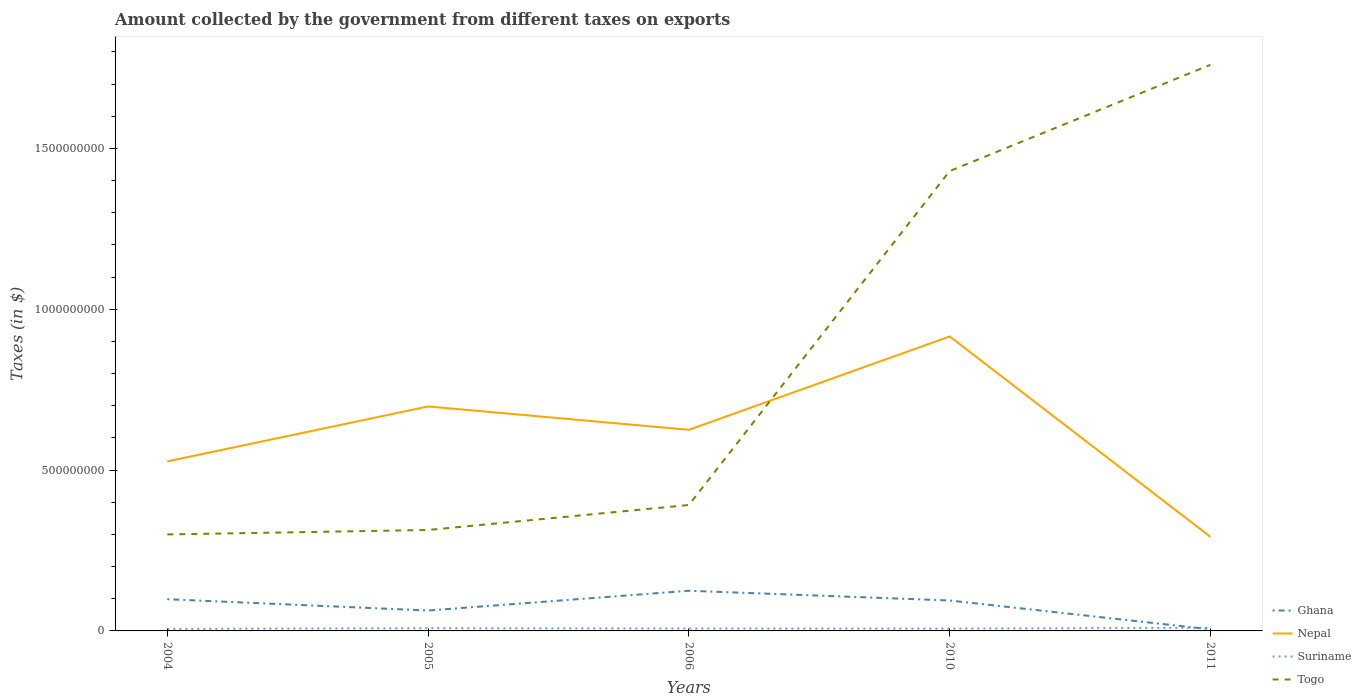Does the line corresponding to Togo intersect with the line corresponding to Ghana?
Keep it short and to the point. No. Across all years, what is the maximum amount collected by the government from taxes on exports in Togo?
Make the answer very short. 3.00e+08. What is the total amount collected by the government from taxes on exports in Suriname in the graph?
Provide a succinct answer. -3.63e+06. What is the difference between the highest and the second highest amount collected by the government from taxes on exports in Suriname?
Your answer should be compact. 3.63e+06. What is the difference between the highest and the lowest amount collected by the government from taxes on exports in Nepal?
Offer a very short reply. 3. Is the amount collected by the government from taxes on exports in Togo strictly greater than the amount collected by the government from taxes on exports in Ghana over the years?
Your response must be concise. No. How many lines are there?
Give a very brief answer. 4. What is the difference between two consecutive major ticks on the Y-axis?
Give a very brief answer. 5.00e+08. Are the values on the major ticks of Y-axis written in scientific E-notation?
Provide a succinct answer. No. Does the graph contain any zero values?
Make the answer very short. No. Where does the legend appear in the graph?
Give a very brief answer. Bottom right. How many legend labels are there?
Your response must be concise. 4. How are the legend labels stacked?
Provide a succinct answer. Vertical. What is the title of the graph?
Keep it short and to the point. Amount collected by the government from different taxes on exports. Does "Timor-Leste" appear as one of the legend labels in the graph?
Your answer should be very brief. No. What is the label or title of the Y-axis?
Offer a terse response. Taxes (in $). What is the Taxes (in $) in Ghana in 2004?
Provide a short and direct response. 9.86e+07. What is the Taxes (in $) of Nepal in 2004?
Give a very brief answer. 5.27e+08. What is the Taxes (in $) of Suriname in 2004?
Offer a very short reply. 6.30e+06. What is the Taxes (in $) in Togo in 2004?
Keep it short and to the point. 3.00e+08. What is the Taxes (in $) of Ghana in 2005?
Provide a succinct answer. 6.34e+07. What is the Taxes (in $) in Nepal in 2005?
Offer a terse response. 6.98e+08. What is the Taxes (in $) of Suriname in 2005?
Offer a very short reply. 8.52e+06. What is the Taxes (in $) of Togo in 2005?
Your answer should be very brief. 3.14e+08. What is the Taxes (in $) in Ghana in 2006?
Your answer should be very brief. 1.25e+08. What is the Taxes (in $) in Nepal in 2006?
Give a very brief answer. 6.25e+08. What is the Taxes (in $) in Suriname in 2006?
Give a very brief answer. 7.49e+06. What is the Taxes (in $) of Togo in 2006?
Offer a terse response. 3.91e+08. What is the Taxes (in $) of Ghana in 2010?
Your response must be concise. 9.47e+07. What is the Taxes (in $) in Nepal in 2010?
Offer a very short reply. 9.15e+08. What is the Taxes (in $) of Suriname in 2010?
Your answer should be very brief. 7.16e+06. What is the Taxes (in $) of Togo in 2010?
Provide a short and direct response. 1.43e+09. What is the Taxes (in $) of Ghana in 2011?
Offer a very short reply. 5.00e+06. What is the Taxes (in $) in Nepal in 2011?
Provide a succinct answer. 2.92e+08. What is the Taxes (in $) of Suriname in 2011?
Offer a very short reply. 9.93e+06. What is the Taxes (in $) in Togo in 2011?
Your answer should be compact. 1.76e+09. Across all years, what is the maximum Taxes (in $) in Ghana?
Keep it short and to the point. 1.25e+08. Across all years, what is the maximum Taxes (in $) in Nepal?
Ensure brevity in your answer.  9.15e+08. Across all years, what is the maximum Taxes (in $) in Suriname?
Your answer should be compact. 9.93e+06. Across all years, what is the maximum Taxes (in $) of Togo?
Provide a short and direct response. 1.76e+09. Across all years, what is the minimum Taxes (in $) of Nepal?
Offer a very short reply. 2.92e+08. Across all years, what is the minimum Taxes (in $) of Suriname?
Ensure brevity in your answer.  6.30e+06. Across all years, what is the minimum Taxes (in $) of Togo?
Give a very brief answer. 3.00e+08. What is the total Taxes (in $) of Ghana in the graph?
Give a very brief answer. 3.87e+08. What is the total Taxes (in $) of Nepal in the graph?
Offer a very short reply. 3.06e+09. What is the total Taxes (in $) in Suriname in the graph?
Offer a very short reply. 3.94e+07. What is the total Taxes (in $) in Togo in the graph?
Your response must be concise. 4.19e+09. What is the difference between the Taxes (in $) of Ghana in 2004 and that in 2005?
Offer a very short reply. 3.51e+07. What is the difference between the Taxes (in $) of Nepal in 2004 and that in 2005?
Give a very brief answer. -1.71e+08. What is the difference between the Taxes (in $) of Suriname in 2004 and that in 2005?
Give a very brief answer. -2.22e+06. What is the difference between the Taxes (in $) in Togo in 2004 and that in 2005?
Your answer should be very brief. -1.38e+07. What is the difference between the Taxes (in $) of Ghana in 2004 and that in 2006?
Provide a succinct answer. -2.63e+07. What is the difference between the Taxes (in $) in Nepal in 2004 and that in 2006?
Provide a succinct answer. -9.82e+07. What is the difference between the Taxes (in $) in Suriname in 2004 and that in 2006?
Keep it short and to the point. -1.19e+06. What is the difference between the Taxes (in $) of Togo in 2004 and that in 2006?
Ensure brevity in your answer.  -9.15e+07. What is the difference between the Taxes (in $) of Ghana in 2004 and that in 2010?
Offer a terse response. 3.92e+06. What is the difference between the Taxes (in $) of Nepal in 2004 and that in 2010?
Offer a very short reply. -3.88e+08. What is the difference between the Taxes (in $) in Suriname in 2004 and that in 2010?
Give a very brief answer. -8.60e+05. What is the difference between the Taxes (in $) of Togo in 2004 and that in 2010?
Your response must be concise. -1.13e+09. What is the difference between the Taxes (in $) in Ghana in 2004 and that in 2011?
Keep it short and to the point. 9.36e+07. What is the difference between the Taxes (in $) in Nepal in 2004 and that in 2011?
Give a very brief answer. 2.35e+08. What is the difference between the Taxes (in $) in Suriname in 2004 and that in 2011?
Provide a short and direct response. -3.63e+06. What is the difference between the Taxes (in $) of Togo in 2004 and that in 2011?
Give a very brief answer. -1.46e+09. What is the difference between the Taxes (in $) of Ghana in 2005 and that in 2006?
Provide a short and direct response. -6.14e+07. What is the difference between the Taxes (in $) in Nepal in 2005 and that in 2006?
Ensure brevity in your answer.  7.26e+07. What is the difference between the Taxes (in $) in Suriname in 2005 and that in 2006?
Your response must be concise. 1.03e+06. What is the difference between the Taxes (in $) of Togo in 2005 and that in 2006?
Your response must be concise. -7.76e+07. What is the difference between the Taxes (in $) in Ghana in 2005 and that in 2010?
Ensure brevity in your answer.  -3.12e+07. What is the difference between the Taxes (in $) in Nepal in 2005 and that in 2010?
Make the answer very short. -2.18e+08. What is the difference between the Taxes (in $) of Suriname in 2005 and that in 2010?
Offer a very short reply. 1.36e+06. What is the difference between the Taxes (in $) of Togo in 2005 and that in 2010?
Give a very brief answer. -1.12e+09. What is the difference between the Taxes (in $) of Ghana in 2005 and that in 2011?
Ensure brevity in your answer.  5.84e+07. What is the difference between the Taxes (in $) of Nepal in 2005 and that in 2011?
Give a very brief answer. 4.06e+08. What is the difference between the Taxes (in $) of Suriname in 2005 and that in 2011?
Provide a short and direct response. -1.41e+06. What is the difference between the Taxes (in $) in Togo in 2005 and that in 2011?
Provide a short and direct response. -1.45e+09. What is the difference between the Taxes (in $) of Ghana in 2006 and that in 2010?
Offer a very short reply. 3.02e+07. What is the difference between the Taxes (in $) of Nepal in 2006 and that in 2010?
Keep it short and to the point. -2.90e+08. What is the difference between the Taxes (in $) of Suriname in 2006 and that in 2010?
Give a very brief answer. 3.33e+05. What is the difference between the Taxes (in $) of Togo in 2006 and that in 2010?
Provide a succinct answer. -1.04e+09. What is the difference between the Taxes (in $) of Ghana in 2006 and that in 2011?
Your answer should be compact. 1.20e+08. What is the difference between the Taxes (in $) in Nepal in 2006 and that in 2011?
Offer a very short reply. 3.33e+08. What is the difference between the Taxes (in $) in Suriname in 2006 and that in 2011?
Your response must be concise. -2.44e+06. What is the difference between the Taxes (in $) in Togo in 2006 and that in 2011?
Give a very brief answer. -1.37e+09. What is the difference between the Taxes (in $) of Ghana in 2010 and that in 2011?
Offer a terse response. 8.97e+07. What is the difference between the Taxes (in $) in Nepal in 2010 and that in 2011?
Your response must be concise. 6.23e+08. What is the difference between the Taxes (in $) in Suriname in 2010 and that in 2011?
Provide a succinct answer. -2.77e+06. What is the difference between the Taxes (in $) of Togo in 2010 and that in 2011?
Offer a very short reply. -3.30e+08. What is the difference between the Taxes (in $) in Ghana in 2004 and the Taxes (in $) in Nepal in 2005?
Offer a very short reply. -5.99e+08. What is the difference between the Taxes (in $) of Ghana in 2004 and the Taxes (in $) of Suriname in 2005?
Your answer should be compact. 9.01e+07. What is the difference between the Taxes (in $) in Ghana in 2004 and the Taxes (in $) in Togo in 2005?
Give a very brief answer. -2.15e+08. What is the difference between the Taxes (in $) in Nepal in 2004 and the Taxes (in $) in Suriname in 2005?
Provide a succinct answer. 5.19e+08. What is the difference between the Taxes (in $) of Nepal in 2004 and the Taxes (in $) of Togo in 2005?
Provide a short and direct response. 2.13e+08. What is the difference between the Taxes (in $) in Suriname in 2004 and the Taxes (in $) in Togo in 2005?
Offer a very short reply. -3.08e+08. What is the difference between the Taxes (in $) in Ghana in 2004 and the Taxes (in $) in Nepal in 2006?
Your response must be concise. -5.27e+08. What is the difference between the Taxes (in $) of Ghana in 2004 and the Taxes (in $) of Suriname in 2006?
Provide a short and direct response. 9.11e+07. What is the difference between the Taxes (in $) in Ghana in 2004 and the Taxes (in $) in Togo in 2006?
Offer a very short reply. -2.93e+08. What is the difference between the Taxes (in $) in Nepal in 2004 and the Taxes (in $) in Suriname in 2006?
Ensure brevity in your answer.  5.20e+08. What is the difference between the Taxes (in $) of Nepal in 2004 and the Taxes (in $) of Togo in 2006?
Provide a short and direct response. 1.36e+08. What is the difference between the Taxes (in $) of Suriname in 2004 and the Taxes (in $) of Togo in 2006?
Your response must be concise. -3.85e+08. What is the difference between the Taxes (in $) in Ghana in 2004 and the Taxes (in $) in Nepal in 2010?
Give a very brief answer. -8.17e+08. What is the difference between the Taxes (in $) in Ghana in 2004 and the Taxes (in $) in Suriname in 2010?
Your response must be concise. 9.14e+07. What is the difference between the Taxes (in $) in Ghana in 2004 and the Taxes (in $) in Togo in 2010?
Provide a succinct answer. -1.33e+09. What is the difference between the Taxes (in $) of Nepal in 2004 and the Taxes (in $) of Suriname in 2010?
Ensure brevity in your answer.  5.20e+08. What is the difference between the Taxes (in $) of Nepal in 2004 and the Taxes (in $) of Togo in 2010?
Make the answer very short. -9.03e+08. What is the difference between the Taxes (in $) in Suriname in 2004 and the Taxes (in $) in Togo in 2010?
Keep it short and to the point. -1.42e+09. What is the difference between the Taxes (in $) of Ghana in 2004 and the Taxes (in $) of Nepal in 2011?
Offer a very short reply. -1.94e+08. What is the difference between the Taxes (in $) in Ghana in 2004 and the Taxes (in $) in Suriname in 2011?
Keep it short and to the point. 8.87e+07. What is the difference between the Taxes (in $) in Ghana in 2004 and the Taxes (in $) in Togo in 2011?
Provide a short and direct response. -1.66e+09. What is the difference between the Taxes (in $) in Nepal in 2004 and the Taxes (in $) in Suriname in 2011?
Give a very brief answer. 5.17e+08. What is the difference between the Taxes (in $) of Nepal in 2004 and the Taxes (in $) of Togo in 2011?
Your response must be concise. -1.23e+09. What is the difference between the Taxes (in $) of Suriname in 2004 and the Taxes (in $) of Togo in 2011?
Offer a terse response. -1.75e+09. What is the difference between the Taxes (in $) in Ghana in 2005 and the Taxes (in $) in Nepal in 2006?
Keep it short and to the point. -5.62e+08. What is the difference between the Taxes (in $) of Ghana in 2005 and the Taxes (in $) of Suriname in 2006?
Keep it short and to the point. 5.60e+07. What is the difference between the Taxes (in $) in Ghana in 2005 and the Taxes (in $) in Togo in 2006?
Your answer should be compact. -3.28e+08. What is the difference between the Taxes (in $) in Nepal in 2005 and the Taxes (in $) in Suriname in 2006?
Your answer should be very brief. 6.90e+08. What is the difference between the Taxes (in $) of Nepal in 2005 and the Taxes (in $) of Togo in 2006?
Your response must be concise. 3.06e+08. What is the difference between the Taxes (in $) in Suriname in 2005 and the Taxes (in $) in Togo in 2006?
Your answer should be very brief. -3.83e+08. What is the difference between the Taxes (in $) of Ghana in 2005 and the Taxes (in $) of Nepal in 2010?
Offer a very short reply. -8.52e+08. What is the difference between the Taxes (in $) of Ghana in 2005 and the Taxes (in $) of Suriname in 2010?
Provide a short and direct response. 5.63e+07. What is the difference between the Taxes (in $) in Ghana in 2005 and the Taxes (in $) in Togo in 2010?
Ensure brevity in your answer.  -1.37e+09. What is the difference between the Taxes (in $) in Nepal in 2005 and the Taxes (in $) in Suriname in 2010?
Offer a terse response. 6.91e+08. What is the difference between the Taxes (in $) of Nepal in 2005 and the Taxes (in $) of Togo in 2010?
Provide a short and direct response. -7.32e+08. What is the difference between the Taxes (in $) of Suriname in 2005 and the Taxes (in $) of Togo in 2010?
Make the answer very short. -1.42e+09. What is the difference between the Taxes (in $) of Ghana in 2005 and the Taxes (in $) of Nepal in 2011?
Ensure brevity in your answer.  -2.29e+08. What is the difference between the Taxes (in $) in Ghana in 2005 and the Taxes (in $) in Suriname in 2011?
Provide a succinct answer. 5.35e+07. What is the difference between the Taxes (in $) in Ghana in 2005 and the Taxes (in $) in Togo in 2011?
Provide a short and direct response. -1.70e+09. What is the difference between the Taxes (in $) in Nepal in 2005 and the Taxes (in $) in Suriname in 2011?
Your answer should be compact. 6.88e+08. What is the difference between the Taxes (in $) in Nepal in 2005 and the Taxes (in $) in Togo in 2011?
Make the answer very short. -1.06e+09. What is the difference between the Taxes (in $) of Suriname in 2005 and the Taxes (in $) of Togo in 2011?
Offer a terse response. -1.75e+09. What is the difference between the Taxes (in $) of Ghana in 2006 and the Taxes (in $) of Nepal in 2010?
Your answer should be compact. -7.91e+08. What is the difference between the Taxes (in $) in Ghana in 2006 and the Taxes (in $) in Suriname in 2010?
Provide a succinct answer. 1.18e+08. What is the difference between the Taxes (in $) of Ghana in 2006 and the Taxes (in $) of Togo in 2010?
Ensure brevity in your answer.  -1.30e+09. What is the difference between the Taxes (in $) in Nepal in 2006 and the Taxes (in $) in Suriname in 2010?
Your response must be concise. 6.18e+08. What is the difference between the Taxes (in $) in Nepal in 2006 and the Taxes (in $) in Togo in 2010?
Keep it short and to the point. -8.04e+08. What is the difference between the Taxes (in $) of Suriname in 2006 and the Taxes (in $) of Togo in 2010?
Your response must be concise. -1.42e+09. What is the difference between the Taxes (in $) of Ghana in 2006 and the Taxes (in $) of Nepal in 2011?
Provide a succinct answer. -1.68e+08. What is the difference between the Taxes (in $) of Ghana in 2006 and the Taxes (in $) of Suriname in 2011?
Offer a very short reply. 1.15e+08. What is the difference between the Taxes (in $) of Ghana in 2006 and the Taxes (in $) of Togo in 2011?
Give a very brief answer. -1.64e+09. What is the difference between the Taxes (in $) in Nepal in 2006 and the Taxes (in $) in Suriname in 2011?
Your answer should be compact. 6.15e+08. What is the difference between the Taxes (in $) in Nepal in 2006 and the Taxes (in $) in Togo in 2011?
Provide a succinct answer. -1.13e+09. What is the difference between the Taxes (in $) in Suriname in 2006 and the Taxes (in $) in Togo in 2011?
Offer a terse response. -1.75e+09. What is the difference between the Taxes (in $) in Ghana in 2010 and the Taxes (in $) in Nepal in 2011?
Keep it short and to the point. -1.98e+08. What is the difference between the Taxes (in $) of Ghana in 2010 and the Taxes (in $) of Suriname in 2011?
Make the answer very short. 8.47e+07. What is the difference between the Taxes (in $) of Ghana in 2010 and the Taxes (in $) of Togo in 2011?
Provide a succinct answer. -1.67e+09. What is the difference between the Taxes (in $) in Nepal in 2010 and the Taxes (in $) in Suriname in 2011?
Your answer should be very brief. 9.06e+08. What is the difference between the Taxes (in $) in Nepal in 2010 and the Taxes (in $) in Togo in 2011?
Offer a terse response. -8.45e+08. What is the difference between the Taxes (in $) of Suriname in 2010 and the Taxes (in $) of Togo in 2011?
Make the answer very short. -1.75e+09. What is the average Taxes (in $) in Ghana per year?
Provide a short and direct response. 7.73e+07. What is the average Taxes (in $) in Nepal per year?
Your response must be concise. 6.12e+08. What is the average Taxes (in $) of Suriname per year?
Make the answer very short. 7.88e+06. What is the average Taxes (in $) of Togo per year?
Make the answer very short. 8.39e+08. In the year 2004, what is the difference between the Taxes (in $) of Ghana and Taxes (in $) of Nepal?
Your answer should be compact. -4.29e+08. In the year 2004, what is the difference between the Taxes (in $) of Ghana and Taxes (in $) of Suriname?
Provide a succinct answer. 9.23e+07. In the year 2004, what is the difference between the Taxes (in $) in Ghana and Taxes (in $) in Togo?
Offer a terse response. -2.01e+08. In the year 2004, what is the difference between the Taxes (in $) in Nepal and Taxes (in $) in Suriname?
Provide a short and direct response. 5.21e+08. In the year 2004, what is the difference between the Taxes (in $) of Nepal and Taxes (in $) of Togo?
Give a very brief answer. 2.27e+08. In the year 2004, what is the difference between the Taxes (in $) of Suriname and Taxes (in $) of Togo?
Offer a very short reply. -2.94e+08. In the year 2005, what is the difference between the Taxes (in $) of Ghana and Taxes (in $) of Nepal?
Your response must be concise. -6.34e+08. In the year 2005, what is the difference between the Taxes (in $) in Ghana and Taxes (in $) in Suriname?
Ensure brevity in your answer.  5.49e+07. In the year 2005, what is the difference between the Taxes (in $) of Ghana and Taxes (in $) of Togo?
Keep it short and to the point. -2.50e+08. In the year 2005, what is the difference between the Taxes (in $) in Nepal and Taxes (in $) in Suriname?
Give a very brief answer. 6.89e+08. In the year 2005, what is the difference between the Taxes (in $) of Nepal and Taxes (in $) of Togo?
Provide a succinct answer. 3.84e+08. In the year 2005, what is the difference between the Taxes (in $) of Suriname and Taxes (in $) of Togo?
Ensure brevity in your answer.  -3.05e+08. In the year 2006, what is the difference between the Taxes (in $) of Ghana and Taxes (in $) of Nepal?
Ensure brevity in your answer.  -5.00e+08. In the year 2006, what is the difference between the Taxes (in $) of Ghana and Taxes (in $) of Suriname?
Offer a terse response. 1.17e+08. In the year 2006, what is the difference between the Taxes (in $) in Ghana and Taxes (in $) in Togo?
Ensure brevity in your answer.  -2.67e+08. In the year 2006, what is the difference between the Taxes (in $) of Nepal and Taxes (in $) of Suriname?
Your answer should be compact. 6.18e+08. In the year 2006, what is the difference between the Taxes (in $) in Nepal and Taxes (in $) in Togo?
Provide a succinct answer. 2.34e+08. In the year 2006, what is the difference between the Taxes (in $) in Suriname and Taxes (in $) in Togo?
Give a very brief answer. -3.84e+08. In the year 2010, what is the difference between the Taxes (in $) of Ghana and Taxes (in $) of Nepal?
Give a very brief answer. -8.21e+08. In the year 2010, what is the difference between the Taxes (in $) in Ghana and Taxes (in $) in Suriname?
Offer a terse response. 8.75e+07. In the year 2010, what is the difference between the Taxes (in $) in Ghana and Taxes (in $) in Togo?
Give a very brief answer. -1.34e+09. In the year 2010, what is the difference between the Taxes (in $) in Nepal and Taxes (in $) in Suriname?
Offer a terse response. 9.08e+08. In the year 2010, what is the difference between the Taxes (in $) of Nepal and Taxes (in $) of Togo?
Provide a short and direct response. -5.14e+08. In the year 2010, what is the difference between the Taxes (in $) of Suriname and Taxes (in $) of Togo?
Keep it short and to the point. -1.42e+09. In the year 2011, what is the difference between the Taxes (in $) in Ghana and Taxes (in $) in Nepal?
Offer a terse response. -2.87e+08. In the year 2011, what is the difference between the Taxes (in $) in Ghana and Taxes (in $) in Suriname?
Provide a short and direct response. -4.93e+06. In the year 2011, what is the difference between the Taxes (in $) in Ghana and Taxes (in $) in Togo?
Keep it short and to the point. -1.76e+09. In the year 2011, what is the difference between the Taxes (in $) in Nepal and Taxes (in $) in Suriname?
Your response must be concise. 2.82e+08. In the year 2011, what is the difference between the Taxes (in $) in Nepal and Taxes (in $) in Togo?
Keep it short and to the point. -1.47e+09. In the year 2011, what is the difference between the Taxes (in $) of Suriname and Taxes (in $) of Togo?
Ensure brevity in your answer.  -1.75e+09. What is the ratio of the Taxes (in $) in Ghana in 2004 to that in 2005?
Offer a very short reply. 1.55. What is the ratio of the Taxes (in $) in Nepal in 2004 to that in 2005?
Provide a short and direct response. 0.76. What is the ratio of the Taxes (in $) in Suriname in 2004 to that in 2005?
Offer a very short reply. 0.74. What is the ratio of the Taxes (in $) of Togo in 2004 to that in 2005?
Your answer should be very brief. 0.96. What is the ratio of the Taxes (in $) of Ghana in 2004 to that in 2006?
Provide a succinct answer. 0.79. What is the ratio of the Taxes (in $) of Nepal in 2004 to that in 2006?
Offer a very short reply. 0.84. What is the ratio of the Taxes (in $) in Suriname in 2004 to that in 2006?
Provide a succinct answer. 0.84. What is the ratio of the Taxes (in $) of Togo in 2004 to that in 2006?
Provide a short and direct response. 0.77. What is the ratio of the Taxes (in $) of Ghana in 2004 to that in 2010?
Provide a succinct answer. 1.04. What is the ratio of the Taxes (in $) in Nepal in 2004 to that in 2010?
Provide a short and direct response. 0.58. What is the ratio of the Taxes (in $) in Suriname in 2004 to that in 2010?
Keep it short and to the point. 0.88. What is the ratio of the Taxes (in $) in Togo in 2004 to that in 2010?
Provide a short and direct response. 0.21. What is the ratio of the Taxes (in $) of Ghana in 2004 to that in 2011?
Keep it short and to the point. 19.72. What is the ratio of the Taxes (in $) in Nepal in 2004 to that in 2011?
Offer a terse response. 1.8. What is the ratio of the Taxes (in $) in Suriname in 2004 to that in 2011?
Ensure brevity in your answer.  0.63. What is the ratio of the Taxes (in $) in Togo in 2004 to that in 2011?
Offer a very short reply. 0.17. What is the ratio of the Taxes (in $) in Ghana in 2005 to that in 2006?
Provide a succinct answer. 0.51. What is the ratio of the Taxes (in $) of Nepal in 2005 to that in 2006?
Provide a succinct answer. 1.12. What is the ratio of the Taxes (in $) in Suriname in 2005 to that in 2006?
Keep it short and to the point. 1.14. What is the ratio of the Taxes (in $) of Togo in 2005 to that in 2006?
Ensure brevity in your answer.  0.8. What is the ratio of the Taxes (in $) of Ghana in 2005 to that in 2010?
Your answer should be compact. 0.67. What is the ratio of the Taxes (in $) of Nepal in 2005 to that in 2010?
Your response must be concise. 0.76. What is the ratio of the Taxes (in $) of Suriname in 2005 to that in 2010?
Your answer should be very brief. 1.19. What is the ratio of the Taxes (in $) of Togo in 2005 to that in 2010?
Give a very brief answer. 0.22. What is the ratio of the Taxes (in $) in Ghana in 2005 to that in 2011?
Keep it short and to the point. 12.69. What is the ratio of the Taxes (in $) of Nepal in 2005 to that in 2011?
Offer a terse response. 2.39. What is the ratio of the Taxes (in $) in Suriname in 2005 to that in 2011?
Provide a succinct answer. 0.86. What is the ratio of the Taxes (in $) in Togo in 2005 to that in 2011?
Keep it short and to the point. 0.18. What is the ratio of the Taxes (in $) of Ghana in 2006 to that in 2010?
Give a very brief answer. 1.32. What is the ratio of the Taxes (in $) in Nepal in 2006 to that in 2010?
Provide a short and direct response. 0.68. What is the ratio of the Taxes (in $) in Suriname in 2006 to that in 2010?
Give a very brief answer. 1.05. What is the ratio of the Taxes (in $) of Togo in 2006 to that in 2010?
Ensure brevity in your answer.  0.27. What is the ratio of the Taxes (in $) of Ghana in 2006 to that in 2011?
Give a very brief answer. 24.97. What is the ratio of the Taxes (in $) of Nepal in 2006 to that in 2011?
Ensure brevity in your answer.  2.14. What is the ratio of the Taxes (in $) of Suriname in 2006 to that in 2011?
Offer a very short reply. 0.75. What is the ratio of the Taxes (in $) of Togo in 2006 to that in 2011?
Offer a very short reply. 0.22. What is the ratio of the Taxes (in $) in Ghana in 2010 to that in 2011?
Keep it short and to the point. 18.93. What is the ratio of the Taxes (in $) in Nepal in 2010 to that in 2011?
Your response must be concise. 3.13. What is the ratio of the Taxes (in $) in Suriname in 2010 to that in 2011?
Your answer should be very brief. 0.72. What is the ratio of the Taxes (in $) of Togo in 2010 to that in 2011?
Your answer should be compact. 0.81. What is the difference between the highest and the second highest Taxes (in $) of Ghana?
Offer a terse response. 2.63e+07. What is the difference between the highest and the second highest Taxes (in $) of Nepal?
Ensure brevity in your answer.  2.18e+08. What is the difference between the highest and the second highest Taxes (in $) in Suriname?
Offer a terse response. 1.41e+06. What is the difference between the highest and the second highest Taxes (in $) in Togo?
Offer a terse response. 3.30e+08. What is the difference between the highest and the lowest Taxes (in $) of Ghana?
Keep it short and to the point. 1.20e+08. What is the difference between the highest and the lowest Taxes (in $) in Nepal?
Offer a terse response. 6.23e+08. What is the difference between the highest and the lowest Taxes (in $) of Suriname?
Give a very brief answer. 3.63e+06. What is the difference between the highest and the lowest Taxes (in $) in Togo?
Your answer should be compact. 1.46e+09. 